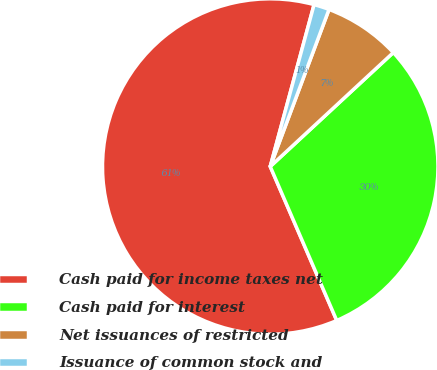Convert chart to OTSL. <chart><loc_0><loc_0><loc_500><loc_500><pie_chart><fcel>Cash paid for income taxes net<fcel>Cash paid for interest<fcel>Net issuances of restricted<fcel>Issuance of common stock and<nl><fcel>60.69%<fcel>30.4%<fcel>7.41%<fcel>1.49%<nl></chart> 